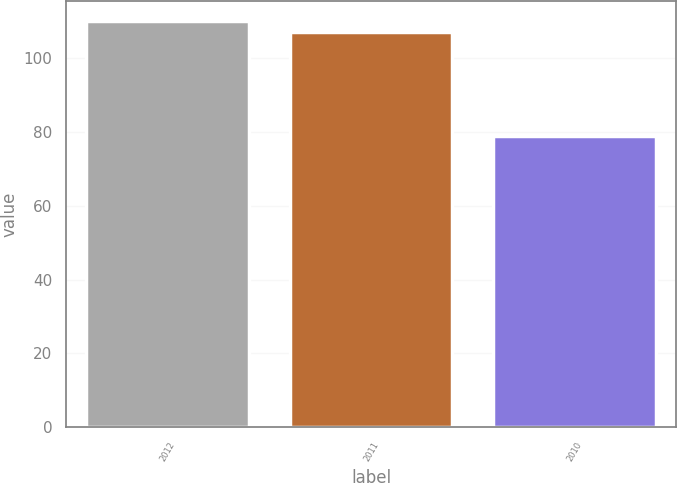Convert chart. <chart><loc_0><loc_0><loc_500><loc_500><bar_chart><fcel>2012<fcel>2011<fcel>2010<nl><fcel>109.9<fcel>107<fcel>79<nl></chart> 